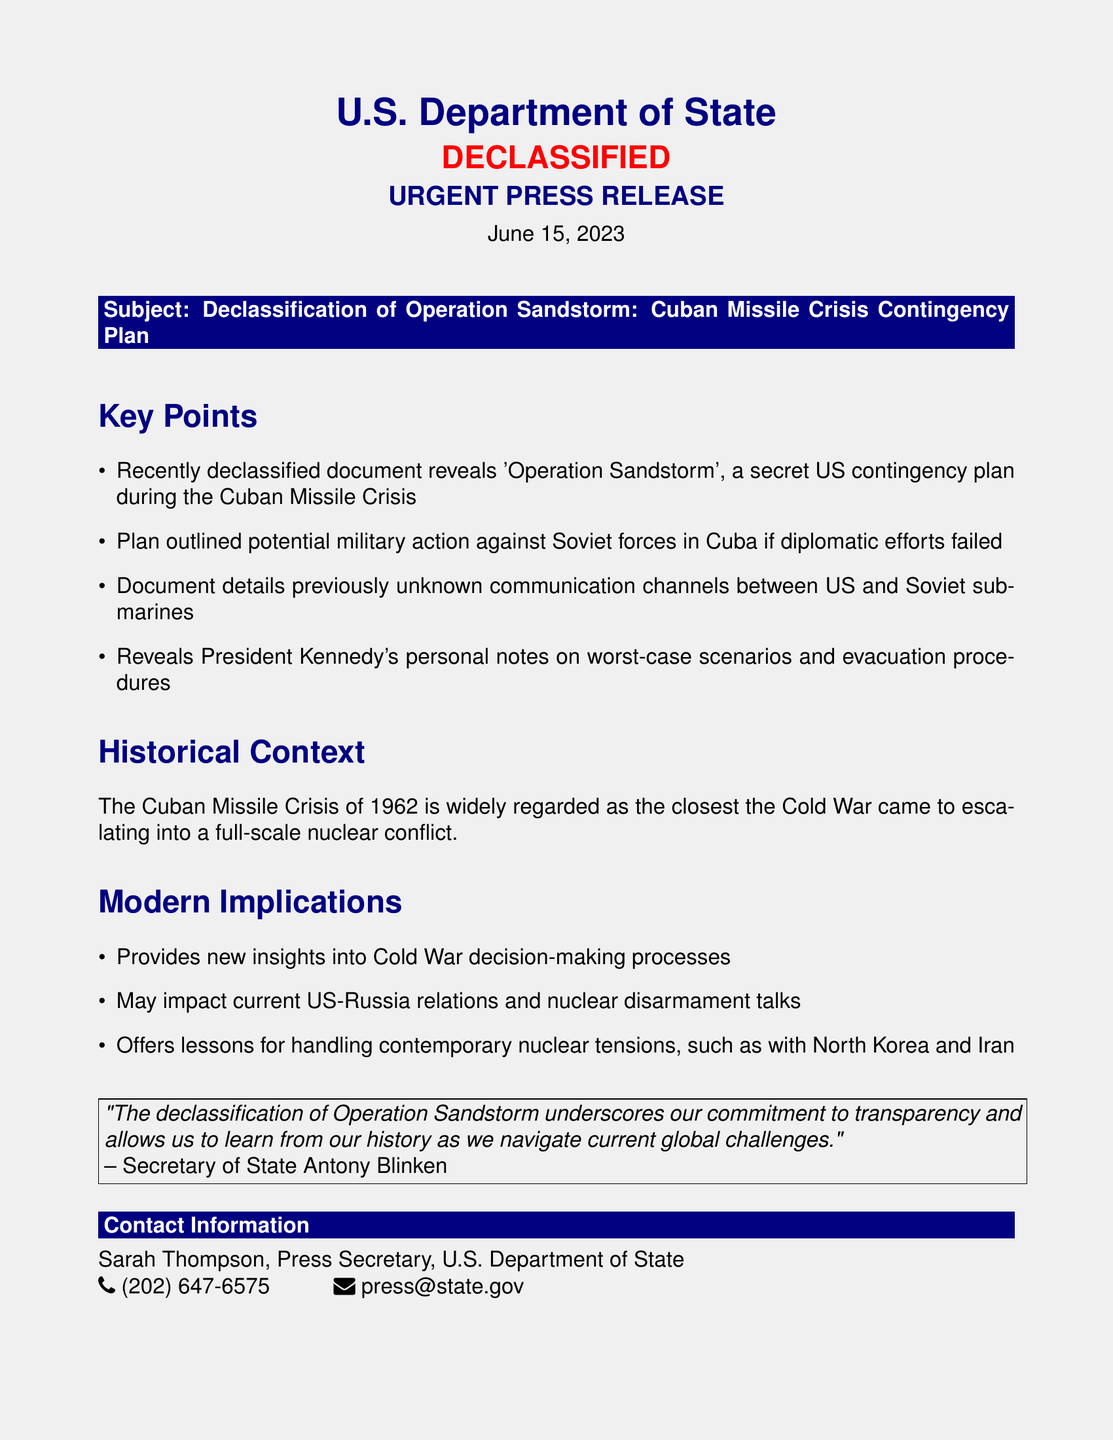What is the subject of the press release? The subject is explicitly stated in the document as "Declassification of Operation Sandstorm: Cuban Missile Crisis Contingency Plan."
Answer: Declassification of Operation Sandstorm: Cuban Missile Crisis Contingency Plan When was this press release issued? The date of the press release is clearly mentioned at the top of the document.
Answer: June 15, 2023 Who is the Secretary of State mentioned in the press release? The Secretary of State is quoted in the document, indicating his name.
Answer: Antony Blinken What is Operation Sandstorm? The document defines Operation Sandstorm as a secret US contingency plan during the Cuban Missile Crisis.
Answer: A secret US contingency plan during the Cuban Missile Crisis What does the document reveal about President Kennedy? The document indicates that President Kennedy's personal notes are included regarding worst-case scenarios and evacuation procedures.
Answer: His personal notes on worst-case scenarios and evacuation procedures What event does the document relate to? The historical context section of the document specifies the event connected to the declassification.
Answer: The Cuban Missile Crisis of 1962 Why is this declassification significant to modern implications? The document states it provides insights into Cold War decision-making and may affect current US-Russia relations.
Answer: It provides new insights into Cold War decision-making processes What department issued this press release? The header of the document identifies the department responsible for the press release.
Answer: U.S. Department of State 